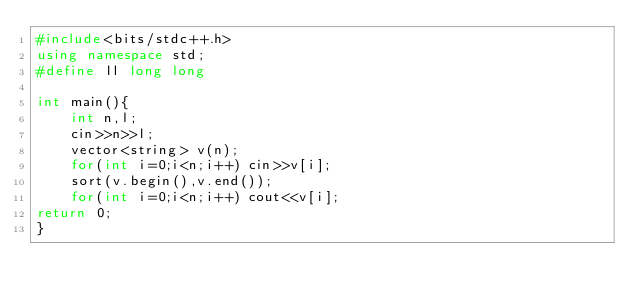Convert code to text. <code><loc_0><loc_0><loc_500><loc_500><_C++_>#include<bits/stdc++.h>
using namespace std;
#define ll long long

int main(){
    int n,l;
    cin>>n>>l;
    vector<string> v(n);
    for(int i=0;i<n;i++) cin>>v[i];
    sort(v.begin(),v.end());
    for(int i=0;i<n;i++) cout<<v[i];
return 0;
}</code> 